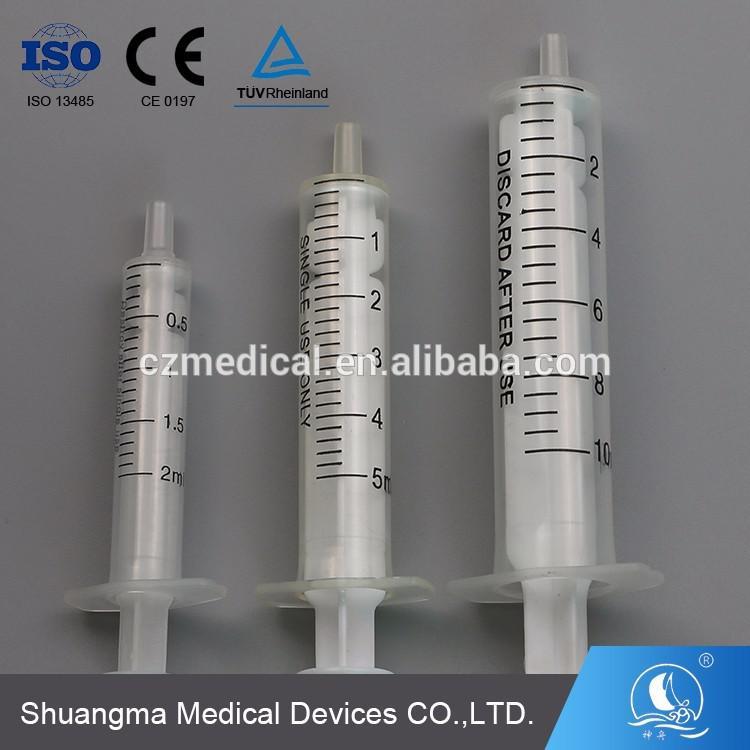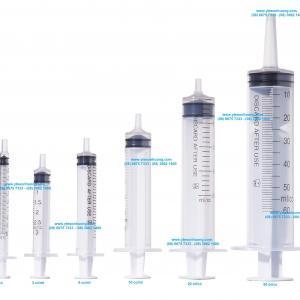The first image is the image on the left, the second image is the image on the right. Given the left and right images, does the statement "The left and right image contains the same number of syringes." hold true? Answer yes or no. No. 